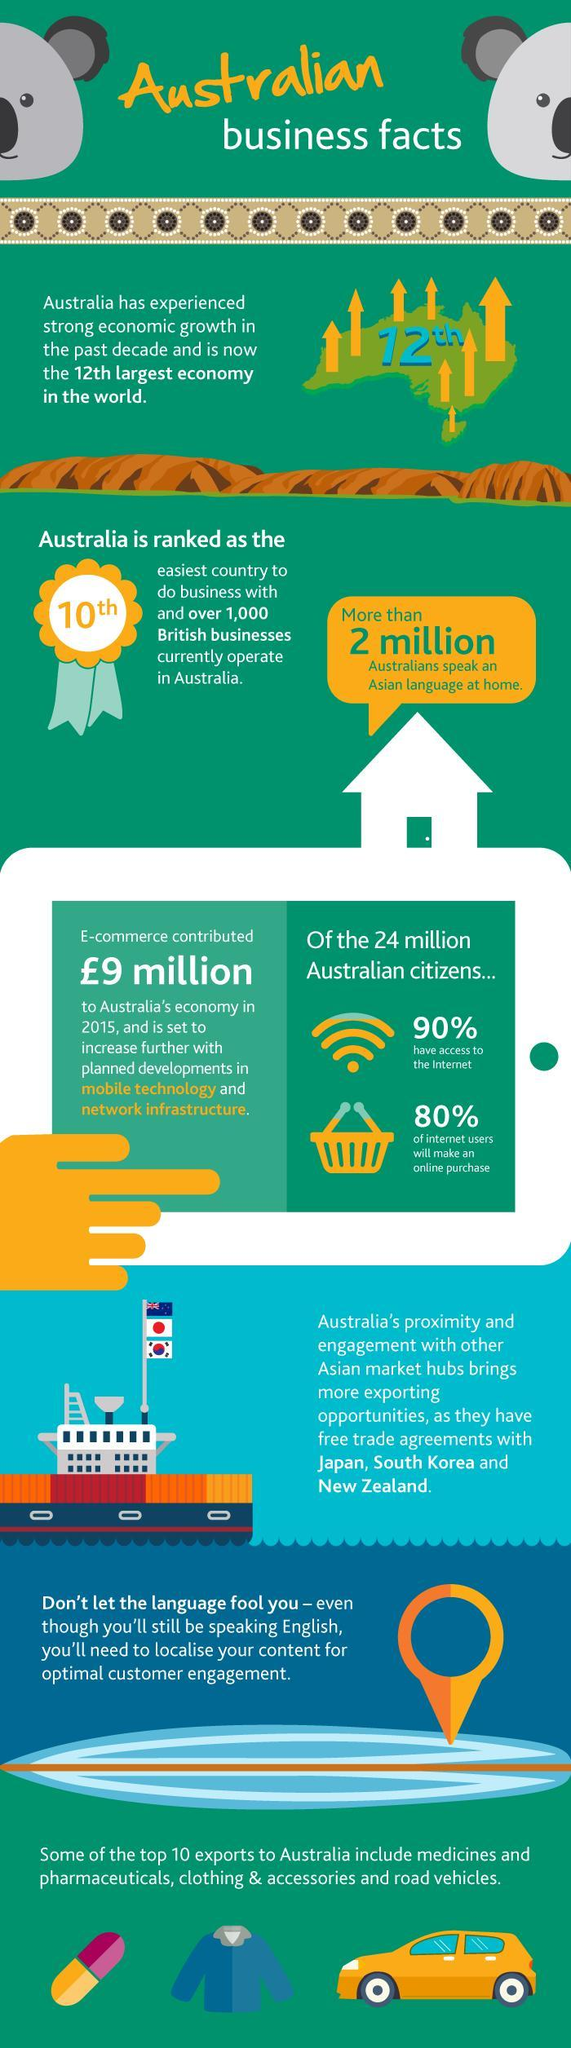What percentage of Australians do not have access to the internet?
Answer the question with a short phrase. 10% What percentage of internet users will make an online purchase in Australia? 80% 